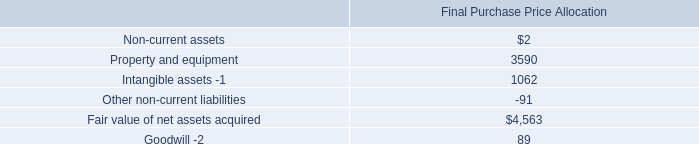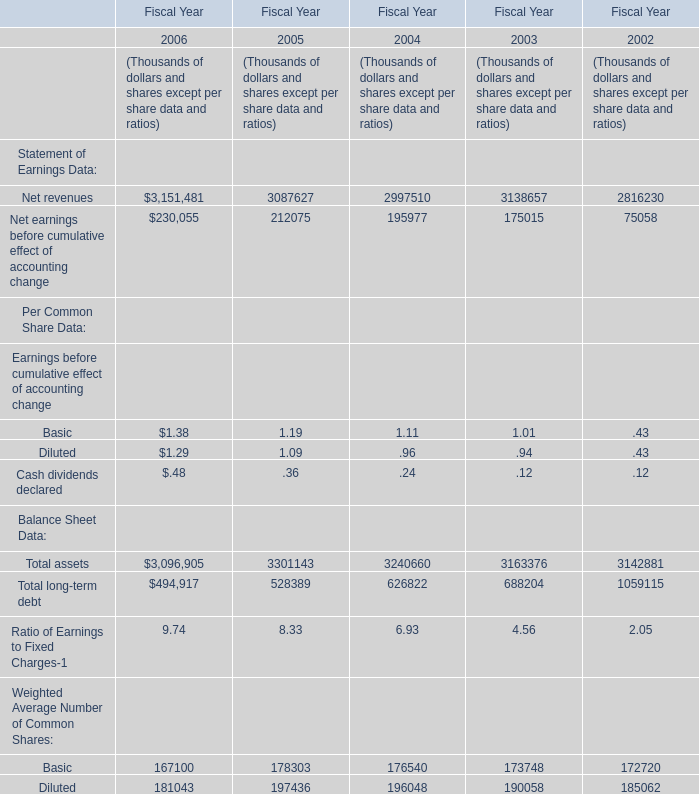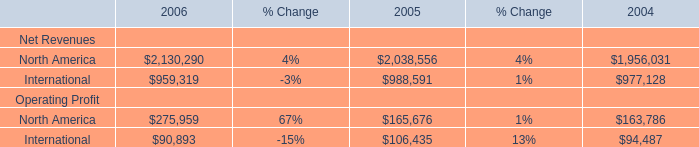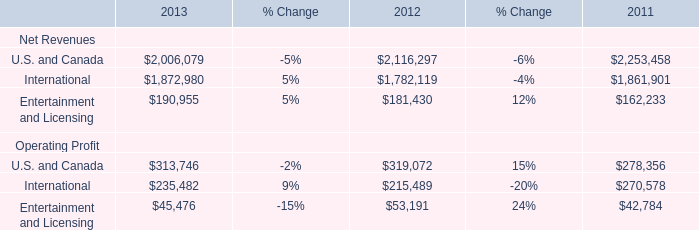Which year is the Total long-term debt greater than 1000000 thousand,in terms of Fiscal Year? 
Answer: 2002. 